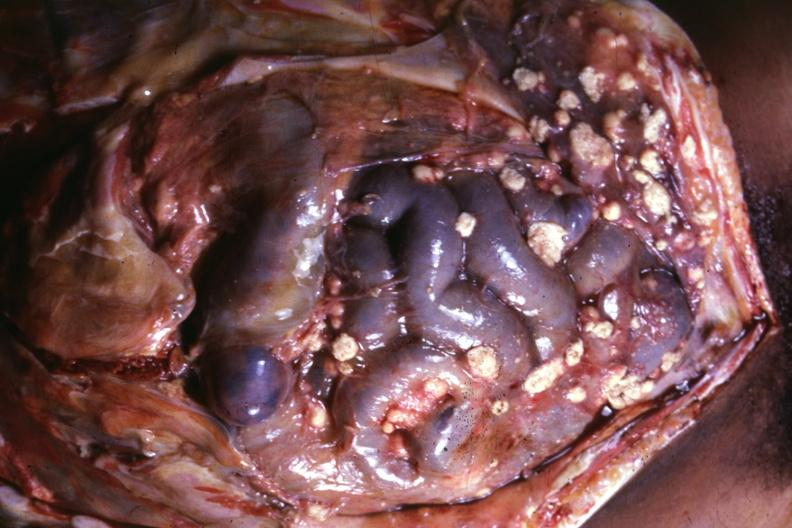where is this area in the body?
Answer the question using a single word or phrase. Abdomen 